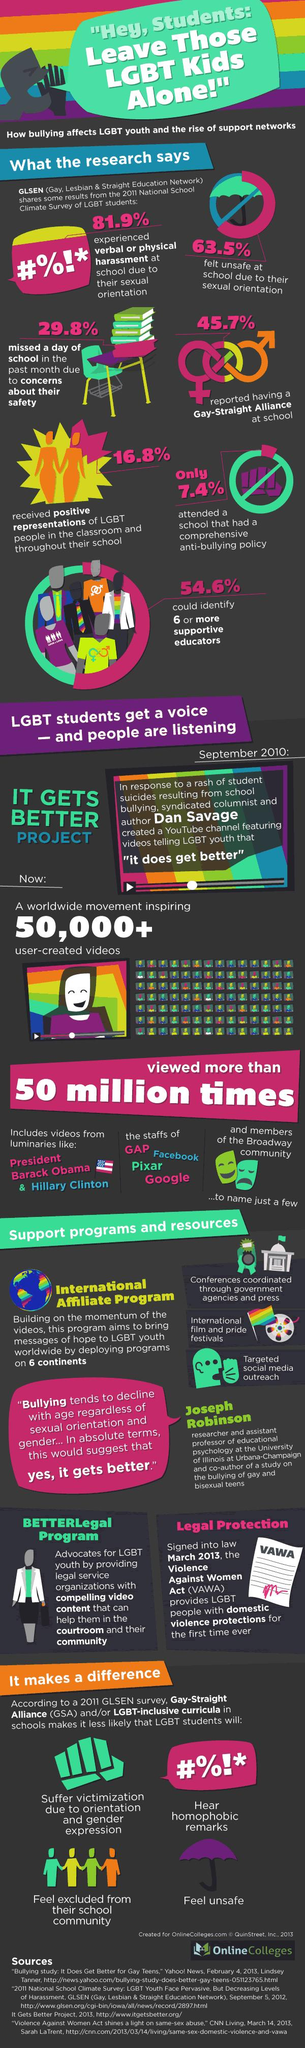Highlight a few significant elements in this photo. According to a recent study, only 7.4% of students study in a school that has the best anti-bullying plans. Approximately 70.2% of students have not missed a day of school due to concerns about their safety. According to the survey, 45.7% of students reported experiencing issues related to their sexuality. 